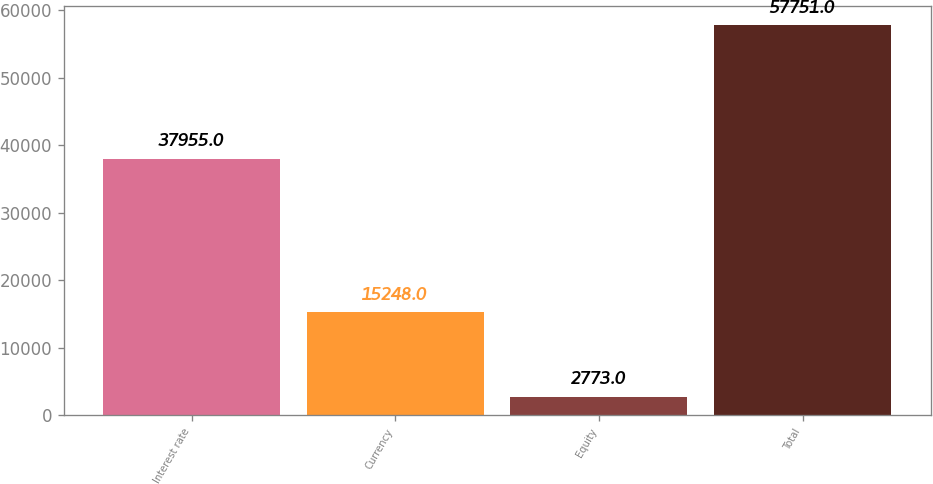<chart> <loc_0><loc_0><loc_500><loc_500><bar_chart><fcel>Interest rate<fcel>Currency<fcel>Equity<fcel>Total<nl><fcel>37955<fcel>15248<fcel>2773<fcel>57751<nl></chart> 